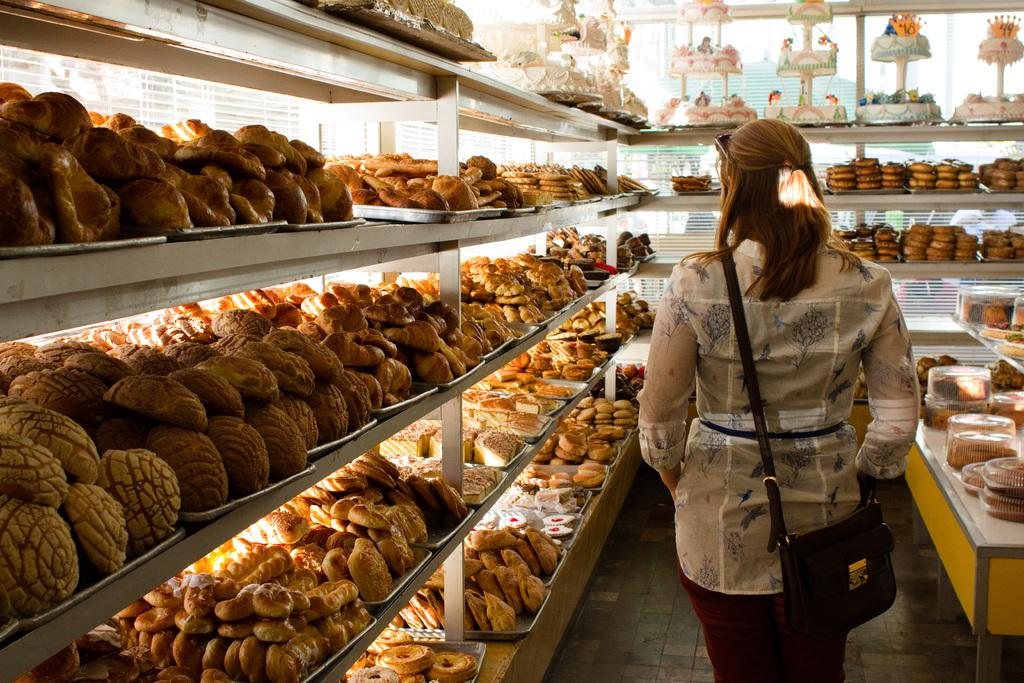What can be seen on the racks in the image? There is a group of food items on the racks in the image. Who or what is beside the racks in the image? There is a person beside the racks in the image. What is located on the right side of the image? There are food items on a table on the right side of the image. What is the income of the person standing beside the racks in the image? There is no information about the person's income in the image. Does the person have a tail in the image? There is no tail visible on the person in the image. 